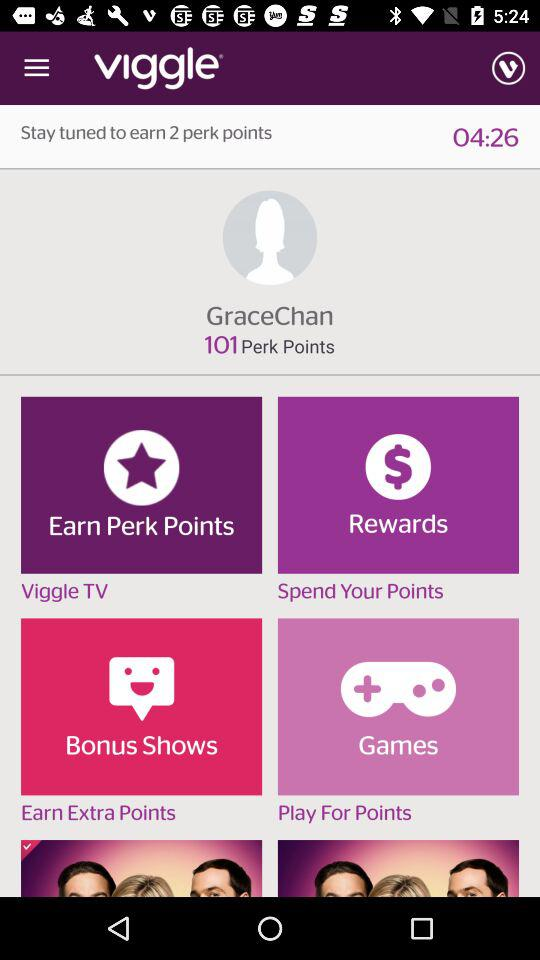How long should we stay tuned in to earn two perk points? You should stay tuned in for 4 minutes 26 seconds to earn two perk points. 